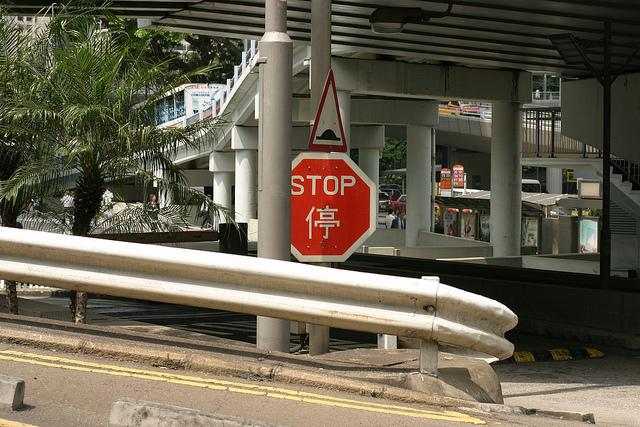What device is used to ensure people stop here? Please explain your reasoning. speedbump. A raised section of road will slow a car down. 